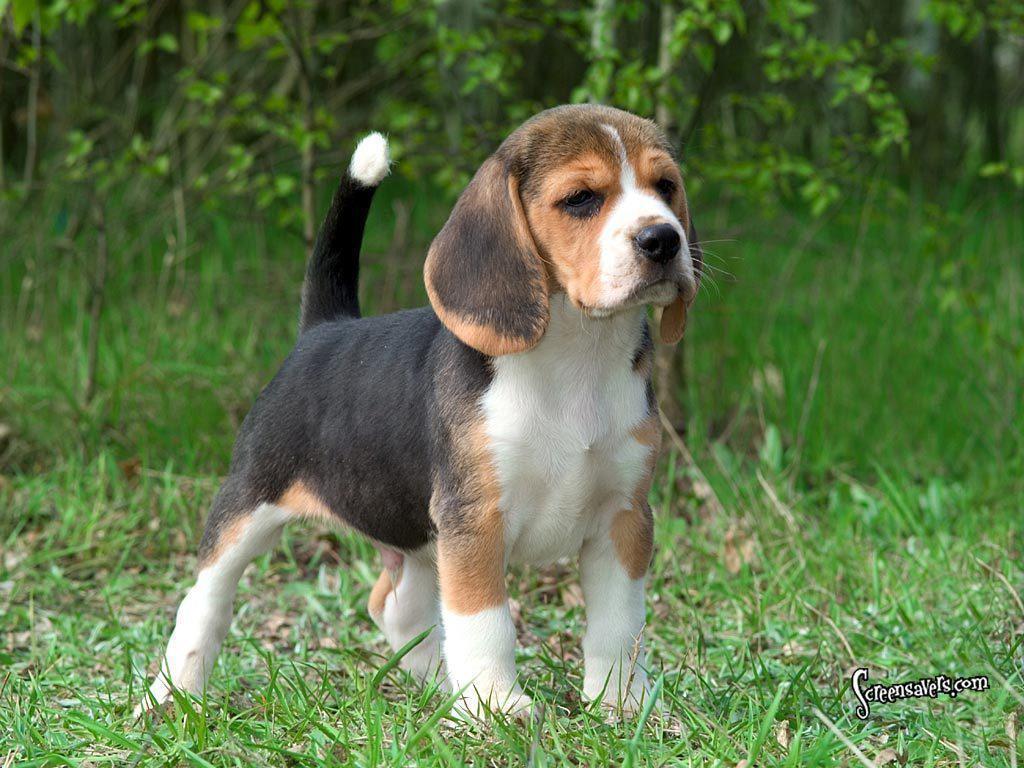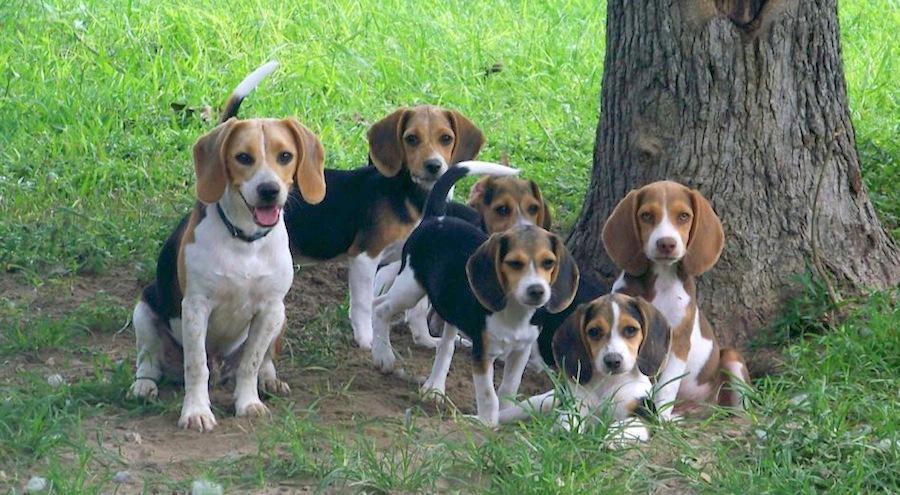The first image is the image on the left, the second image is the image on the right. Considering the images on both sides, is "There are more than seven dogs." valid? Answer yes or no. No. The first image is the image on the left, the second image is the image on the right. Examine the images to the left and right. Is the description "Multiple beagle dogs are posed with a rectangular wooden structure, in one image." accurate? Answer yes or no. No. 